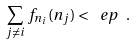<formula> <loc_0><loc_0><loc_500><loc_500>\sum _ { j \ne i } f _ { n _ { i } } ( n _ { j } ) < \ e p \ .</formula> 